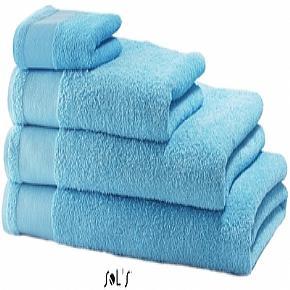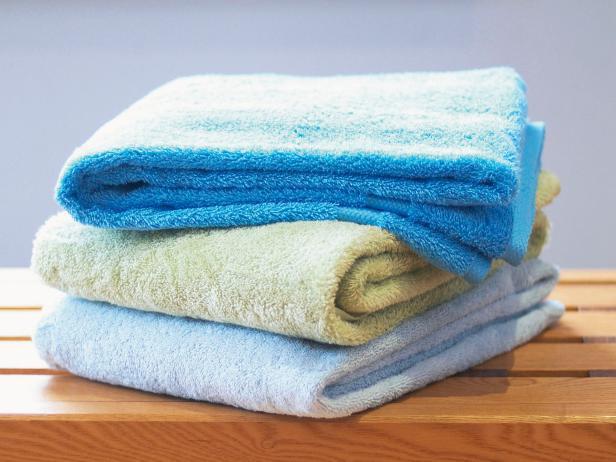The first image is the image on the left, the second image is the image on the right. Analyze the images presented: Is the assertion "There are four towels on the left and three towels on the right, all folded neatly" valid? Answer yes or no. Yes. The first image is the image on the left, the second image is the image on the right. For the images displayed, is the sentence "A stack of three or more towels has folded washcloths on top." factually correct? Answer yes or no. Yes. 